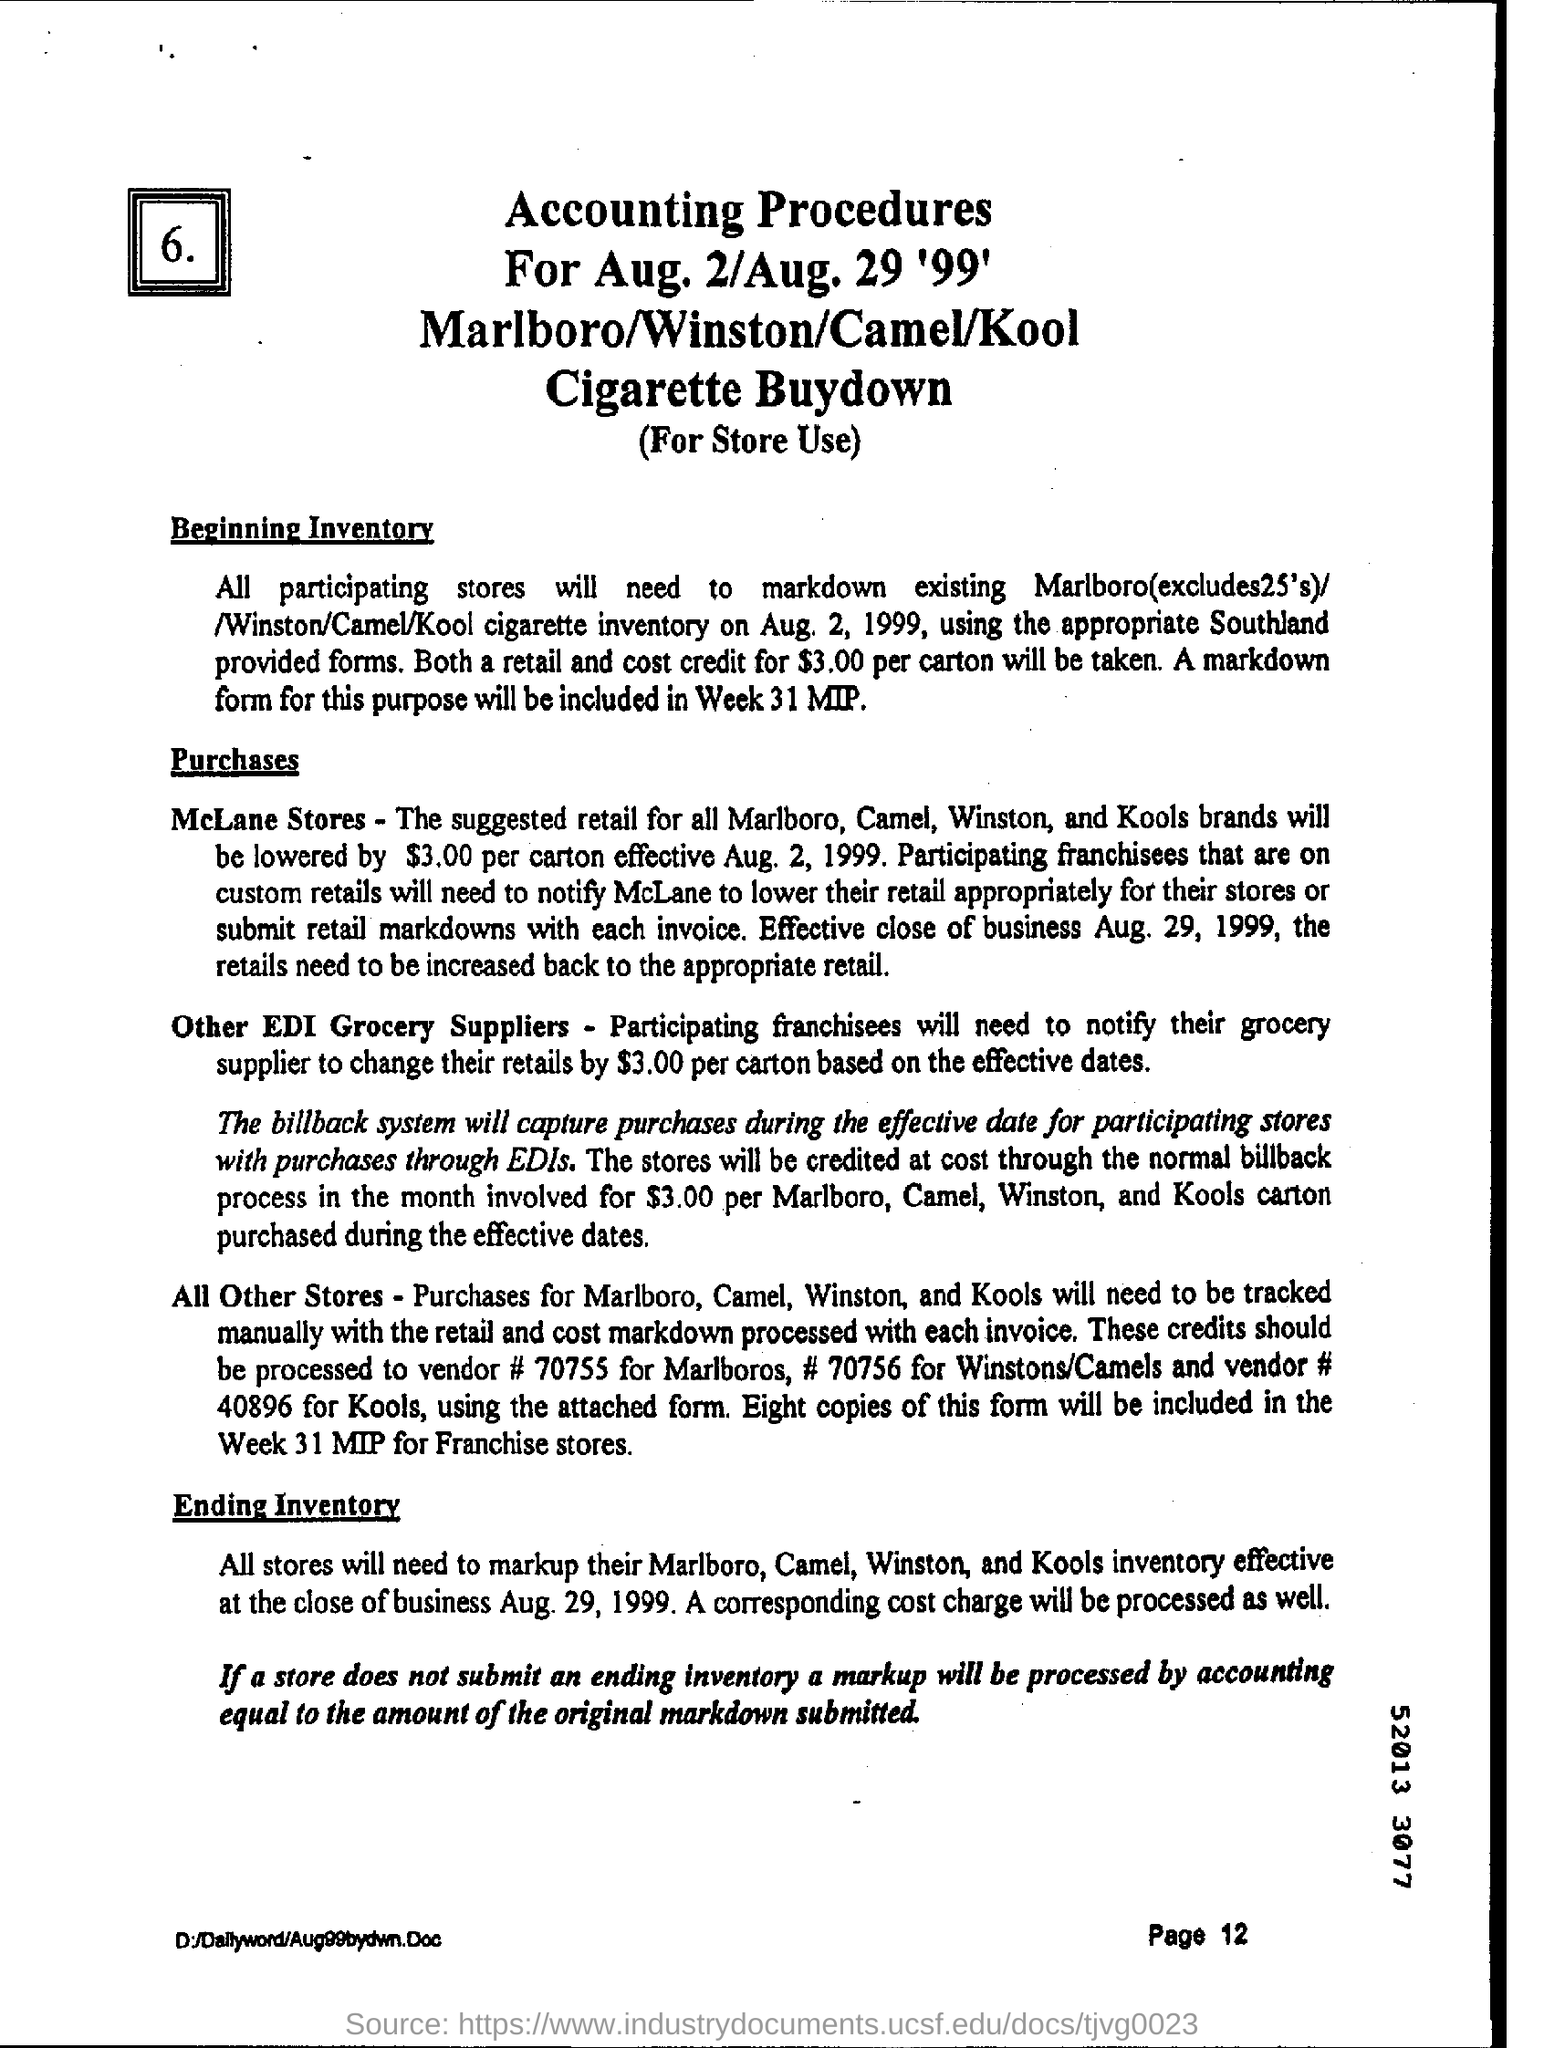Can you summarize the key points regarding inventory mentioned in the document? Certainly! Participating stores must mark down existing cigarette inventory on August 2, 1999, and all stores must then markup their inventory by the close of business on August 29, 1999. Additionally, there's mention of capturing purchases through EDIs, the involved costs and credits for the markdowns, and specific procedures for McLane Stores versus other stores. How do the procedures differ between McLane Stores and other stores? McLane Stores are set to lower retail prices based on centralized instructions and process markdowns with each invoice. Other stores have to manually track purchases and process markdowns with specific vendor numbers and forms. There's an emphasis on the system of credits and billbacks. 